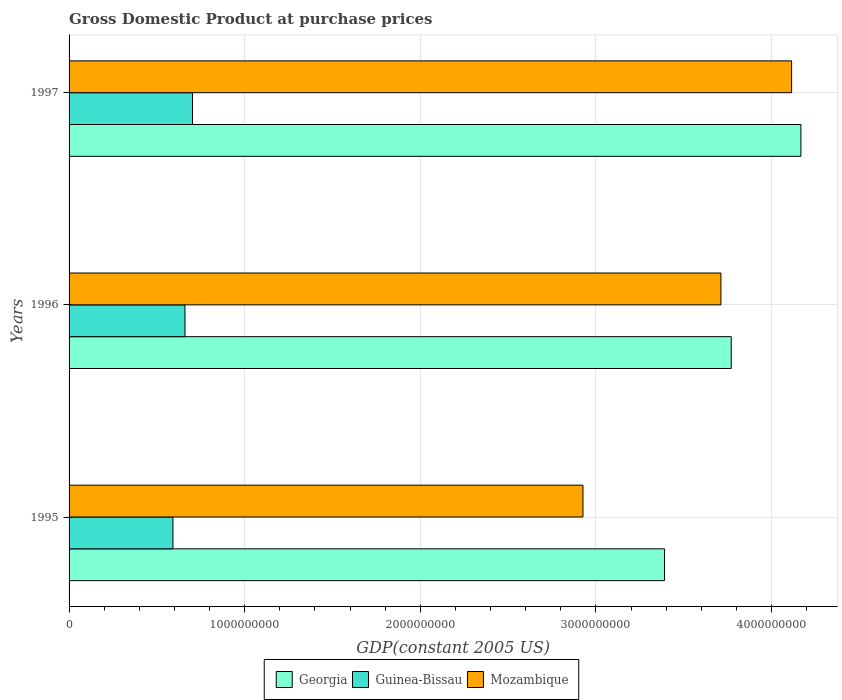How many bars are there on the 1st tick from the top?
Offer a very short reply. 3. In how many cases, is the number of bars for a given year not equal to the number of legend labels?
Ensure brevity in your answer.  0. What is the GDP at purchase prices in Georgia in 1997?
Your answer should be compact. 4.17e+09. Across all years, what is the maximum GDP at purchase prices in Guinea-Bissau?
Ensure brevity in your answer.  7.03e+08. Across all years, what is the minimum GDP at purchase prices in Guinea-Bissau?
Your answer should be very brief. 5.91e+08. In which year was the GDP at purchase prices in Mozambique maximum?
Ensure brevity in your answer.  1997. In which year was the GDP at purchase prices in Georgia minimum?
Provide a short and direct response. 1995. What is the total GDP at purchase prices in Mozambique in the graph?
Provide a succinct answer. 1.08e+1. What is the difference between the GDP at purchase prices in Georgia in 1996 and that in 1997?
Ensure brevity in your answer.  -3.97e+08. What is the difference between the GDP at purchase prices in Georgia in 1995 and the GDP at purchase prices in Mozambique in 1997?
Your response must be concise. -7.23e+08. What is the average GDP at purchase prices in Mozambique per year?
Your response must be concise. 3.58e+09. In the year 1996, what is the difference between the GDP at purchase prices in Georgia and GDP at purchase prices in Mozambique?
Offer a very short reply. 5.88e+07. What is the ratio of the GDP at purchase prices in Mozambique in 1996 to that in 1997?
Your answer should be very brief. 0.9. What is the difference between the highest and the second highest GDP at purchase prices in Georgia?
Provide a short and direct response. 3.97e+08. What is the difference between the highest and the lowest GDP at purchase prices in Guinea-Bissau?
Provide a short and direct response. 1.11e+08. What does the 2nd bar from the top in 1995 represents?
Your answer should be compact. Guinea-Bissau. What does the 1st bar from the bottom in 1995 represents?
Give a very brief answer. Georgia. Is it the case that in every year, the sum of the GDP at purchase prices in Georgia and GDP at purchase prices in Guinea-Bissau is greater than the GDP at purchase prices in Mozambique?
Provide a succinct answer. Yes. How many years are there in the graph?
Provide a succinct answer. 3. What is the difference between two consecutive major ticks on the X-axis?
Ensure brevity in your answer.  1.00e+09. Are the values on the major ticks of X-axis written in scientific E-notation?
Make the answer very short. No. Does the graph contain grids?
Your answer should be compact. Yes. Where does the legend appear in the graph?
Provide a short and direct response. Bottom center. How many legend labels are there?
Your response must be concise. 3. What is the title of the graph?
Keep it short and to the point. Gross Domestic Product at purchase prices. What is the label or title of the X-axis?
Provide a short and direct response. GDP(constant 2005 US). What is the label or title of the Y-axis?
Provide a succinct answer. Years. What is the GDP(constant 2005 US) in Georgia in 1995?
Offer a very short reply. 3.39e+09. What is the GDP(constant 2005 US) of Guinea-Bissau in 1995?
Offer a very short reply. 5.91e+08. What is the GDP(constant 2005 US) of Mozambique in 1995?
Your answer should be very brief. 2.93e+09. What is the GDP(constant 2005 US) of Georgia in 1996?
Keep it short and to the point. 3.77e+09. What is the GDP(constant 2005 US) of Guinea-Bissau in 1996?
Your answer should be compact. 6.60e+08. What is the GDP(constant 2005 US) of Mozambique in 1996?
Your answer should be compact. 3.71e+09. What is the GDP(constant 2005 US) in Georgia in 1997?
Give a very brief answer. 4.17e+09. What is the GDP(constant 2005 US) in Guinea-Bissau in 1997?
Your answer should be compact. 7.03e+08. What is the GDP(constant 2005 US) in Mozambique in 1997?
Make the answer very short. 4.11e+09. Across all years, what is the maximum GDP(constant 2005 US) in Georgia?
Your response must be concise. 4.17e+09. Across all years, what is the maximum GDP(constant 2005 US) of Guinea-Bissau?
Your answer should be compact. 7.03e+08. Across all years, what is the maximum GDP(constant 2005 US) in Mozambique?
Provide a short and direct response. 4.11e+09. Across all years, what is the minimum GDP(constant 2005 US) in Georgia?
Provide a succinct answer. 3.39e+09. Across all years, what is the minimum GDP(constant 2005 US) of Guinea-Bissau?
Give a very brief answer. 5.91e+08. Across all years, what is the minimum GDP(constant 2005 US) of Mozambique?
Provide a short and direct response. 2.93e+09. What is the total GDP(constant 2005 US) of Georgia in the graph?
Ensure brevity in your answer.  1.13e+1. What is the total GDP(constant 2005 US) in Guinea-Bissau in the graph?
Make the answer very short. 1.95e+09. What is the total GDP(constant 2005 US) of Mozambique in the graph?
Your response must be concise. 1.08e+1. What is the difference between the GDP(constant 2005 US) in Georgia in 1995 and that in 1996?
Your answer should be very brief. -3.80e+08. What is the difference between the GDP(constant 2005 US) in Guinea-Bissau in 1995 and that in 1996?
Offer a very short reply. -6.86e+07. What is the difference between the GDP(constant 2005 US) in Mozambique in 1995 and that in 1996?
Ensure brevity in your answer.  -7.86e+08. What is the difference between the GDP(constant 2005 US) of Georgia in 1995 and that in 1997?
Ensure brevity in your answer.  -7.76e+08. What is the difference between the GDP(constant 2005 US) in Guinea-Bissau in 1995 and that in 1997?
Offer a terse response. -1.11e+08. What is the difference between the GDP(constant 2005 US) in Mozambique in 1995 and that in 1997?
Give a very brief answer. -1.19e+09. What is the difference between the GDP(constant 2005 US) in Georgia in 1996 and that in 1997?
Give a very brief answer. -3.97e+08. What is the difference between the GDP(constant 2005 US) in Guinea-Bissau in 1996 and that in 1997?
Your answer should be compact. -4.29e+07. What is the difference between the GDP(constant 2005 US) of Mozambique in 1996 and that in 1997?
Provide a succinct answer. -4.02e+08. What is the difference between the GDP(constant 2005 US) in Georgia in 1995 and the GDP(constant 2005 US) in Guinea-Bissau in 1996?
Provide a short and direct response. 2.73e+09. What is the difference between the GDP(constant 2005 US) in Georgia in 1995 and the GDP(constant 2005 US) in Mozambique in 1996?
Keep it short and to the point. -3.21e+08. What is the difference between the GDP(constant 2005 US) in Guinea-Bissau in 1995 and the GDP(constant 2005 US) in Mozambique in 1996?
Provide a short and direct response. -3.12e+09. What is the difference between the GDP(constant 2005 US) of Georgia in 1995 and the GDP(constant 2005 US) of Guinea-Bissau in 1997?
Your answer should be very brief. 2.69e+09. What is the difference between the GDP(constant 2005 US) of Georgia in 1995 and the GDP(constant 2005 US) of Mozambique in 1997?
Make the answer very short. -7.23e+08. What is the difference between the GDP(constant 2005 US) of Guinea-Bissau in 1995 and the GDP(constant 2005 US) of Mozambique in 1997?
Make the answer very short. -3.52e+09. What is the difference between the GDP(constant 2005 US) of Georgia in 1996 and the GDP(constant 2005 US) of Guinea-Bissau in 1997?
Keep it short and to the point. 3.07e+09. What is the difference between the GDP(constant 2005 US) in Georgia in 1996 and the GDP(constant 2005 US) in Mozambique in 1997?
Your answer should be compact. -3.44e+08. What is the difference between the GDP(constant 2005 US) in Guinea-Bissau in 1996 and the GDP(constant 2005 US) in Mozambique in 1997?
Give a very brief answer. -3.45e+09. What is the average GDP(constant 2005 US) of Georgia per year?
Provide a succinct answer. 3.78e+09. What is the average GDP(constant 2005 US) in Guinea-Bissau per year?
Make the answer very short. 6.51e+08. What is the average GDP(constant 2005 US) of Mozambique per year?
Your response must be concise. 3.58e+09. In the year 1995, what is the difference between the GDP(constant 2005 US) in Georgia and GDP(constant 2005 US) in Guinea-Bissau?
Offer a very short reply. 2.80e+09. In the year 1995, what is the difference between the GDP(constant 2005 US) in Georgia and GDP(constant 2005 US) in Mozambique?
Offer a terse response. 4.65e+08. In the year 1995, what is the difference between the GDP(constant 2005 US) of Guinea-Bissau and GDP(constant 2005 US) of Mozambique?
Your answer should be very brief. -2.33e+09. In the year 1996, what is the difference between the GDP(constant 2005 US) of Georgia and GDP(constant 2005 US) of Guinea-Bissau?
Keep it short and to the point. 3.11e+09. In the year 1996, what is the difference between the GDP(constant 2005 US) of Georgia and GDP(constant 2005 US) of Mozambique?
Offer a very short reply. 5.88e+07. In the year 1996, what is the difference between the GDP(constant 2005 US) in Guinea-Bissau and GDP(constant 2005 US) in Mozambique?
Your response must be concise. -3.05e+09. In the year 1997, what is the difference between the GDP(constant 2005 US) in Georgia and GDP(constant 2005 US) in Guinea-Bissau?
Keep it short and to the point. 3.46e+09. In the year 1997, what is the difference between the GDP(constant 2005 US) in Georgia and GDP(constant 2005 US) in Mozambique?
Give a very brief answer. 5.30e+07. In the year 1997, what is the difference between the GDP(constant 2005 US) in Guinea-Bissau and GDP(constant 2005 US) in Mozambique?
Make the answer very short. -3.41e+09. What is the ratio of the GDP(constant 2005 US) in Georgia in 1995 to that in 1996?
Make the answer very short. 0.9. What is the ratio of the GDP(constant 2005 US) of Guinea-Bissau in 1995 to that in 1996?
Make the answer very short. 0.9. What is the ratio of the GDP(constant 2005 US) of Mozambique in 1995 to that in 1996?
Provide a short and direct response. 0.79. What is the ratio of the GDP(constant 2005 US) of Georgia in 1995 to that in 1997?
Your response must be concise. 0.81. What is the ratio of the GDP(constant 2005 US) of Guinea-Bissau in 1995 to that in 1997?
Ensure brevity in your answer.  0.84. What is the ratio of the GDP(constant 2005 US) in Mozambique in 1995 to that in 1997?
Offer a very short reply. 0.71. What is the ratio of the GDP(constant 2005 US) in Georgia in 1996 to that in 1997?
Your answer should be compact. 0.9. What is the ratio of the GDP(constant 2005 US) in Guinea-Bissau in 1996 to that in 1997?
Give a very brief answer. 0.94. What is the ratio of the GDP(constant 2005 US) of Mozambique in 1996 to that in 1997?
Provide a short and direct response. 0.9. What is the difference between the highest and the second highest GDP(constant 2005 US) in Georgia?
Your answer should be very brief. 3.97e+08. What is the difference between the highest and the second highest GDP(constant 2005 US) in Guinea-Bissau?
Your answer should be very brief. 4.29e+07. What is the difference between the highest and the second highest GDP(constant 2005 US) in Mozambique?
Offer a terse response. 4.02e+08. What is the difference between the highest and the lowest GDP(constant 2005 US) in Georgia?
Your answer should be compact. 7.76e+08. What is the difference between the highest and the lowest GDP(constant 2005 US) of Guinea-Bissau?
Make the answer very short. 1.11e+08. What is the difference between the highest and the lowest GDP(constant 2005 US) of Mozambique?
Provide a short and direct response. 1.19e+09. 